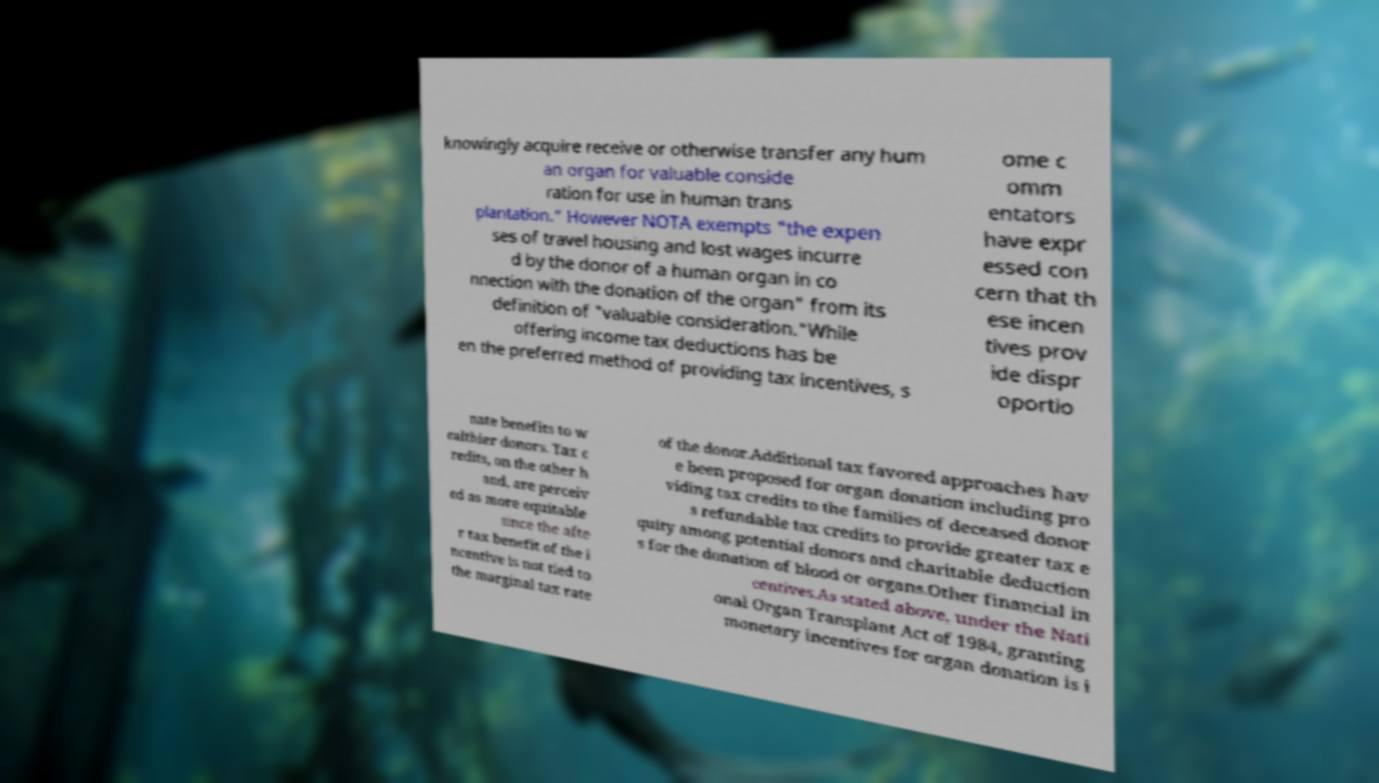For documentation purposes, I need the text within this image transcribed. Could you provide that? knowingly acquire receive or otherwise transfer any hum an organ for valuable conside ration for use in human trans plantation." However NOTA exempts "the expen ses of travel housing and lost wages incurre d by the donor of a human organ in co nnection with the donation of the organ" from its definition of "valuable consideration."While offering income tax deductions has be en the preferred method of providing tax incentives, s ome c omm entators have expr essed con cern that th ese incen tives prov ide dispr oportio nate benefits to w ealthier donors. Tax c redits, on the other h and, are perceiv ed as more equitable since the afte r tax benefit of the i ncentive is not tied to the marginal tax rate of the donor.Additional tax favored approaches hav e been proposed for organ donation including pro viding tax credits to the families of deceased donor s refundable tax credits to provide greater tax e quity among potential donors and charitable deduction s for the donation of blood or organs.Other financial in centives.As stated above, under the Nati onal Organ Transplant Act of 1984, granting monetary incentives for organ donation is i 